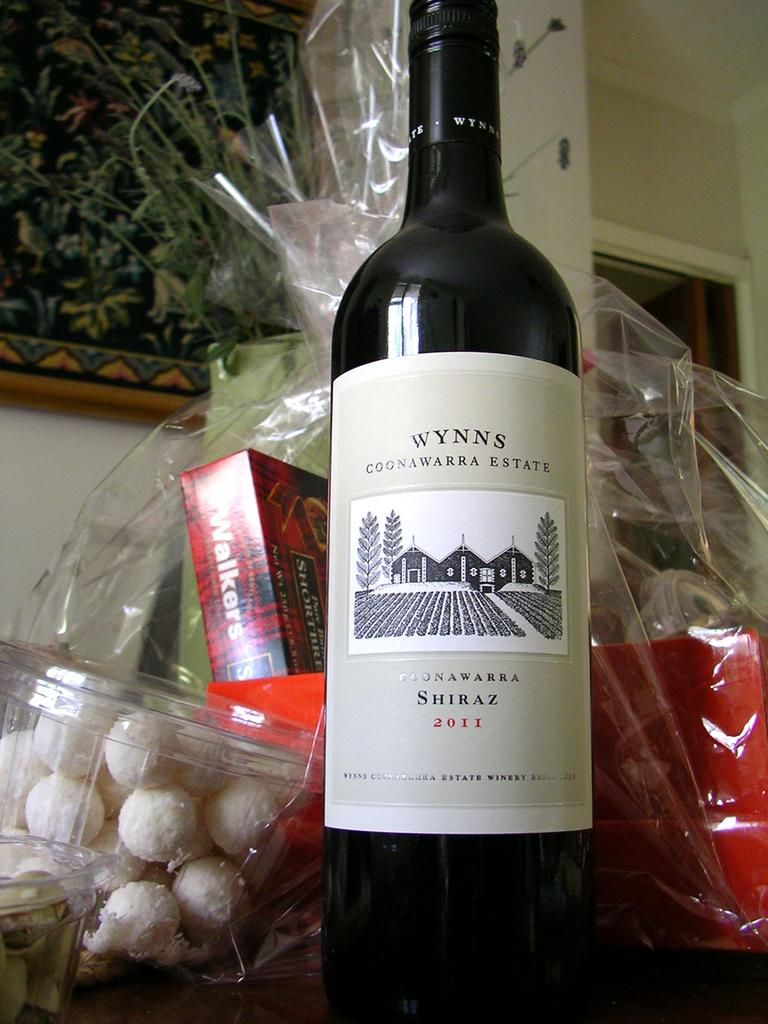<image>
Provide a brief description of the given image. A bottle of Wynns Shiraz next to a basket with treats in it. 